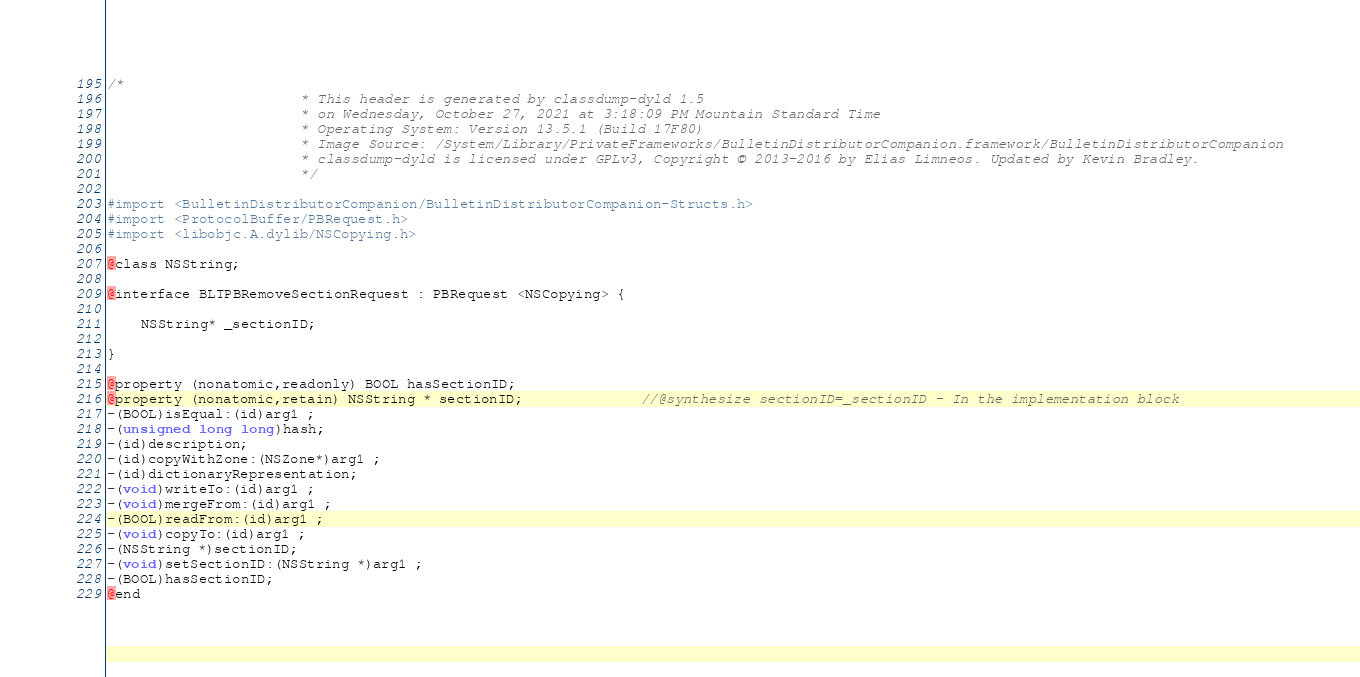Convert code to text. <code><loc_0><loc_0><loc_500><loc_500><_C_>/*
                       * This header is generated by classdump-dyld 1.5
                       * on Wednesday, October 27, 2021 at 3:18:09 PM Mountain Standard Time
                       * Operating System: Version 13.5.1 (Build 17F80)
                       * Image Source: /System/Library/PrivateFrameworks/BulletinDistributorCompanion.framework/BulletinDistributorCompanion
                       * classdump-dyld is licensed under GPLv3, Copyright © 2013-2016 by Elias Limneos. Updated by Kevin Bradley.
                       */

#import <BulletinDistributorCompanion/BulletinDistributorCompanion-Structs.h>
#import <ProtocolBuffer/PBRequest.h>
#import <libobjc.A.dylib/NSCopying.h>

@class NSString;

@interface BLTPBRemoveSectionRequest : PBRequest <NSCopying> {

	NSString* _sectionID;

}

@property (nonatomic,readonly) BOOL hasSectionID; 
@property (nonatomic,retain) NSString * sectionID;              //@synthesize sectionID=_sectionID - In the implementation block
-(BOOL)isEqual:(id)arg1 ;
-(unsigned long long)hash;
-(id)description;
-(id)copyWithZone:(NSZone*)arg1 ;
-(id)dictionaryRepresentation;
-(void)writeTo:(id)arg1 ;
-(void)mergeFrom:(id)arg1 ;
-(BOOL)readFrom:(id)arg1 ;
-(void)copyTo:(id)arg1 ;
-(NSString *)sectionID;
-(void)setSectionID:(NSString *)arg1 ;
-(BOOL)hasSectionID;
@end

</code> 